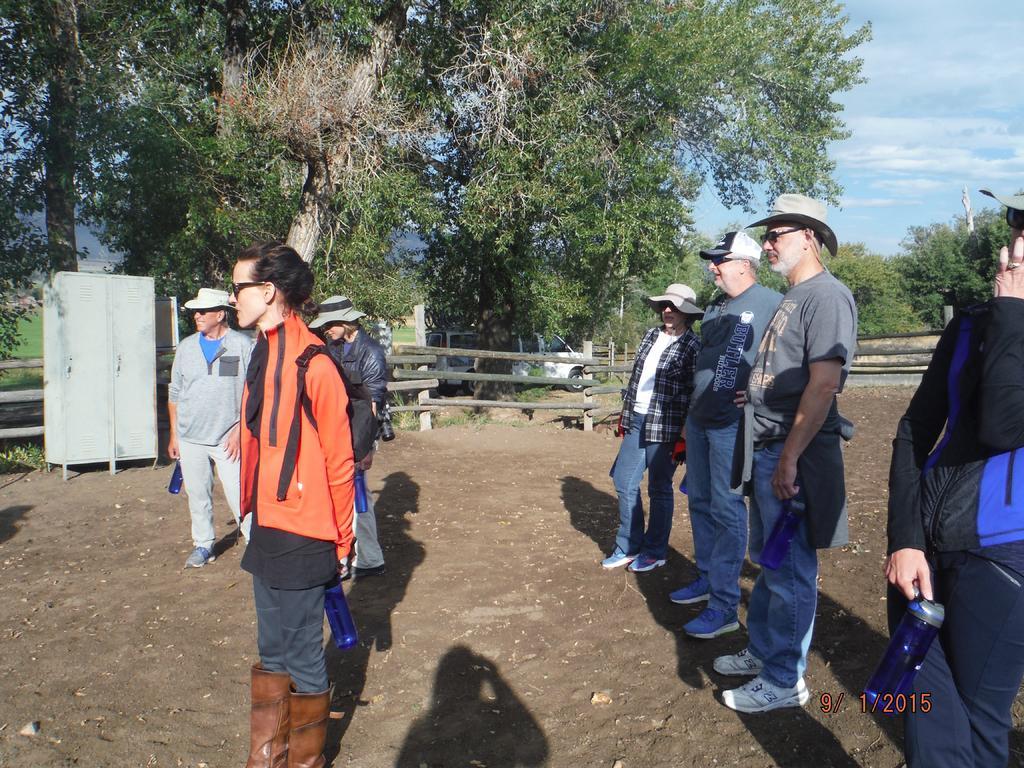Please provide a concise description of this image. This picture is taken outside. Towards the left, there are three people. Towards the right, there are four people. All of them are wearing caps except the woman in orange jacket. In the background, there is a fence, cat, trees and a sky. 